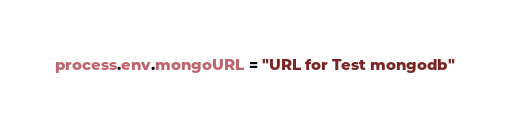<code> <loc_0><loc_0><loc_500><loc_500><_JavaScript_>process.env.mongoURL = "URL for Test mongodb"</code> 